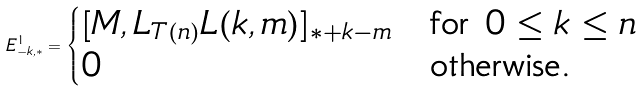Convert formula to latex. <formula><loc_0><loc_0><loc_500><loc_500>E ^ { 1 } _ { - k , * } = \begin{cases} [ M , L _ { T ( n ) } L ( k , m ) ] _ { * + k - m } & \text {for } 0 \leq k \leq n \\ 0 & \text {otherwise.} \end{cases}</formula> 